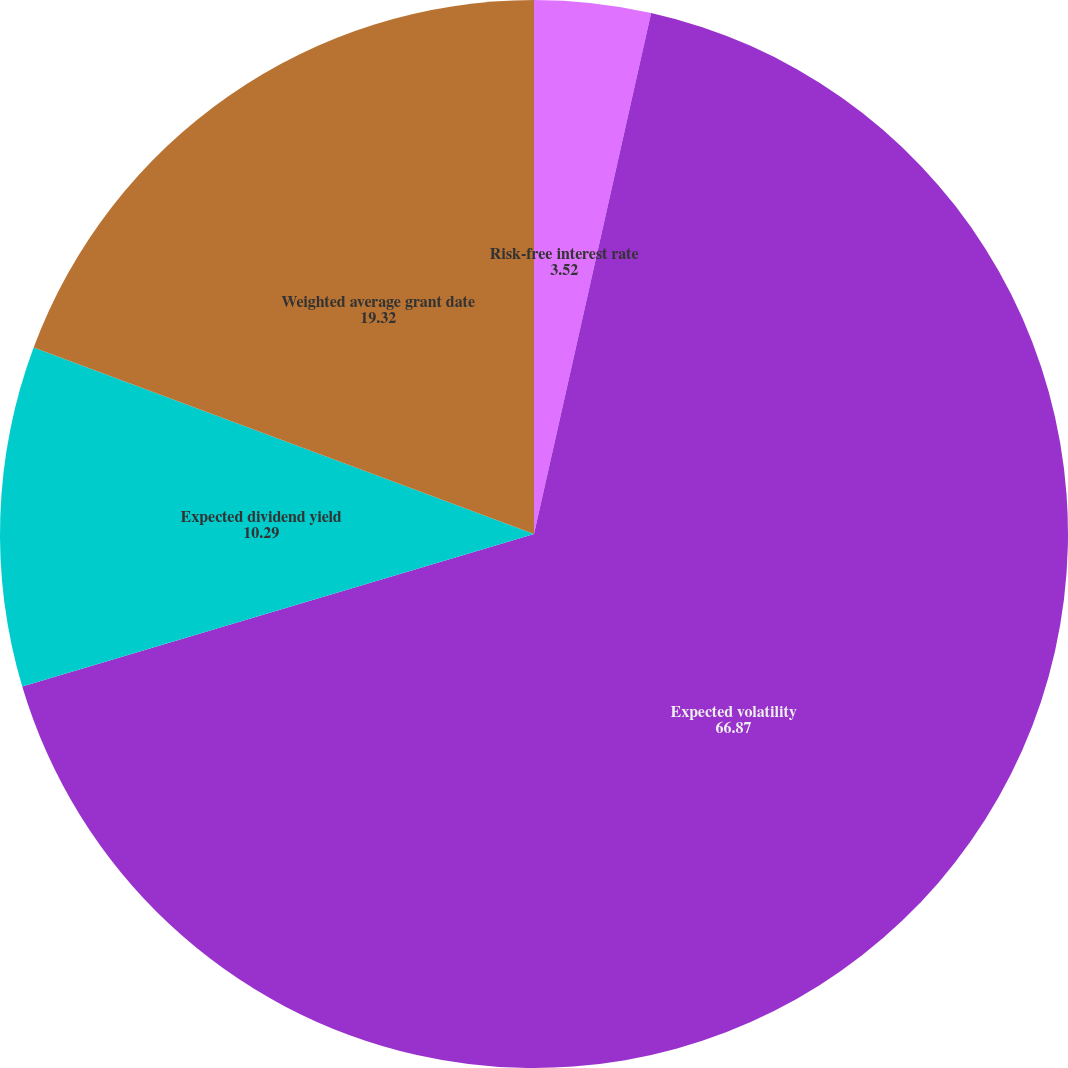<chart> <loc_0><loc_0><loc_500><loc_500><pie_chart><fcel>Risk-free interest rate<fcel>Expected volatility<fcel>Expected dividend yield<fcel>Weighted average grant date<nl><fcel>3.52%<fcel>66.87%<fcel>10.29%<fcel>19.32%<nl></chart> 